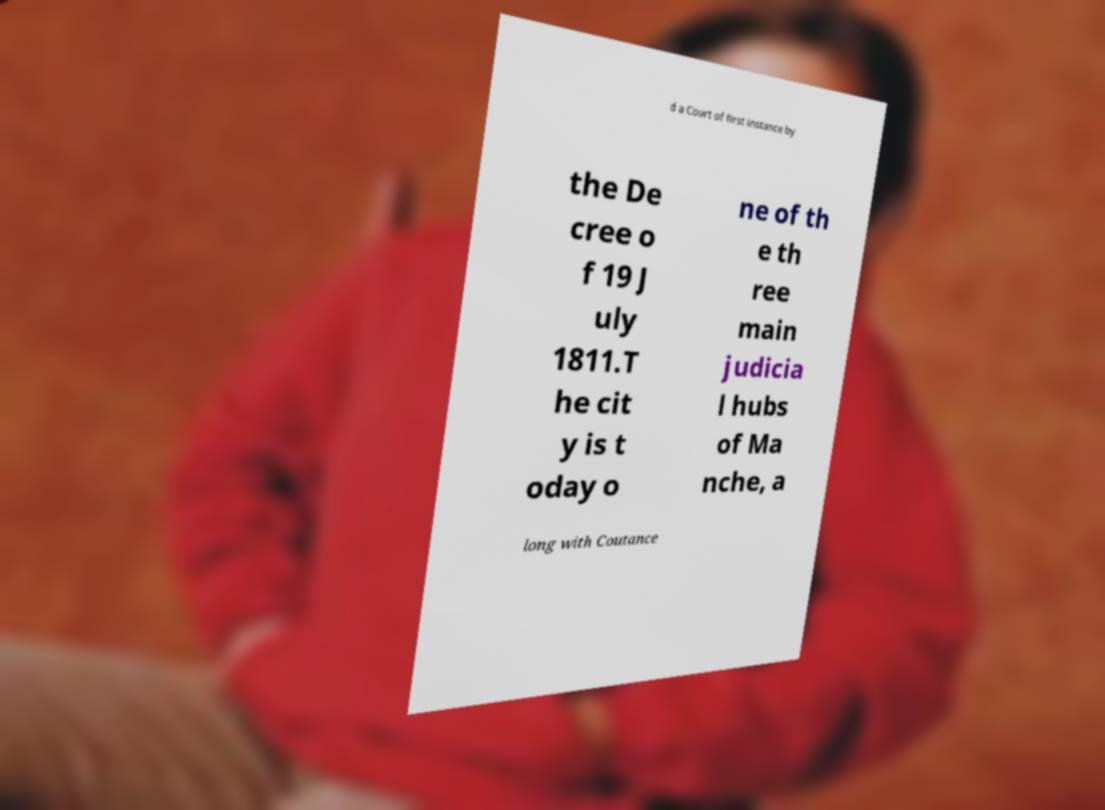There's text embedded in this image that I need extracted. Can you transcribe it verbatim? d a Court of first instance by the De cree o f 19 J uly 1811.T he cit y is t oday o ne of th e th ree main judicia l hubs of Ma nche, a long with Coutance 